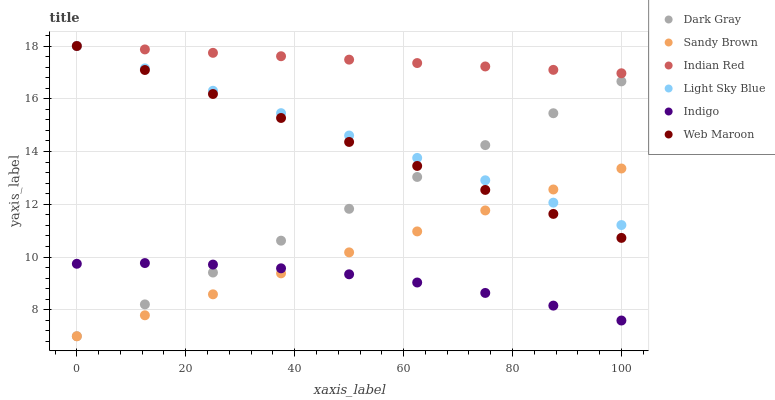Does Indigo have the minimum area under the curve?
Answer yes or no. Yes. Does Indian Red have the maximum area under the curve?
Answer yes or no. Yes. Does Web Maroon have the minimum area under the curve?
Answer yes or no. No. Does Web Maroon have the maximum area under the curve?
Answer yes or no. No. Is Web Maroon the smoothest?
Answer yes or no. Yes. Is Indigo the roughest?
Answer yes or no. Yes. Is Dark Gray the smoothest?
Answer yes or no. No. Is Dark Gray the roughest?
Answer yes or no. No. Does Dark Gray have the lowest value?
Answer yes or no. Yes. Does Web Maroon have the lowest value?
Answer yes or no. No. Does Indian Red have the highest value?
Answer yes or no. Yes. Does Dark Gray have the highest value?
Answer yes or no. No. Is Dark Gray less than Indian Red?
Answer yes or no. Yes. Is Light Sky Blue greater than Indigo?
Answer yes or no. Yes. Does Light Sky Blue intersect Sandy Brown?
Answer yes or no. Yes. Is Light Sky Blue less than Sandy Brown?
Answer yes or no. No. Is Light Sky Blue greater than Sandy Brown?
Answer yes or no. No. Does Dark Gray intersect Indian Red?
Answer yes or no. No. 